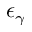Convert formula to latex. <formula><loc_0><loc_0><loc_500><loc_500>\epsilon _ { \gamma }</formula> 